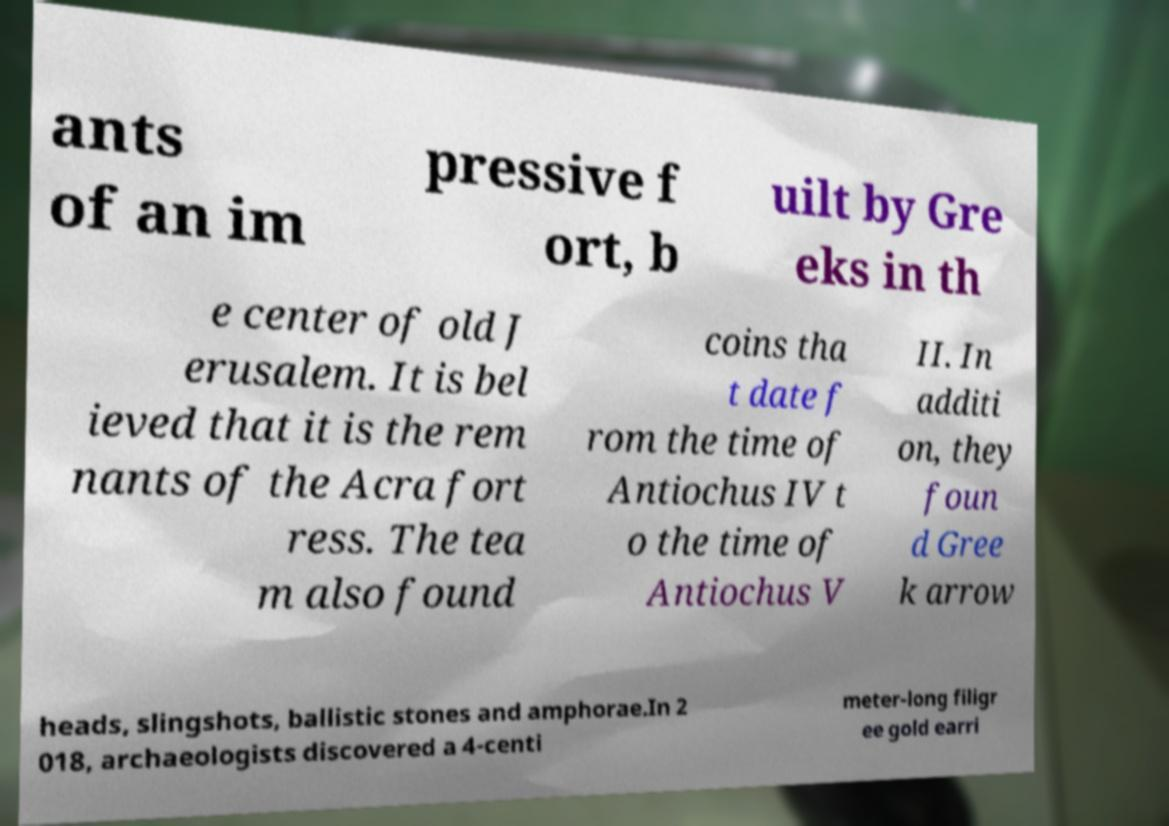I need the written content from this picture converted into text. Can you do that? ants of an im pressive f ort, b uilt by Gre eks in th e center of old J erusalem. It is bel ieved that it is the rem nants of the Acra fort ress. The tea m also found coins tha t date f rom the time of Antiochus IV t o the time of Antiochus V II. In additi on, they foun d Gree k arrow heads, slingshots, ballistic stones and amphorae.In 2 018, archaeologists discovered a 4-centi meter-long filigr ee gold earri 